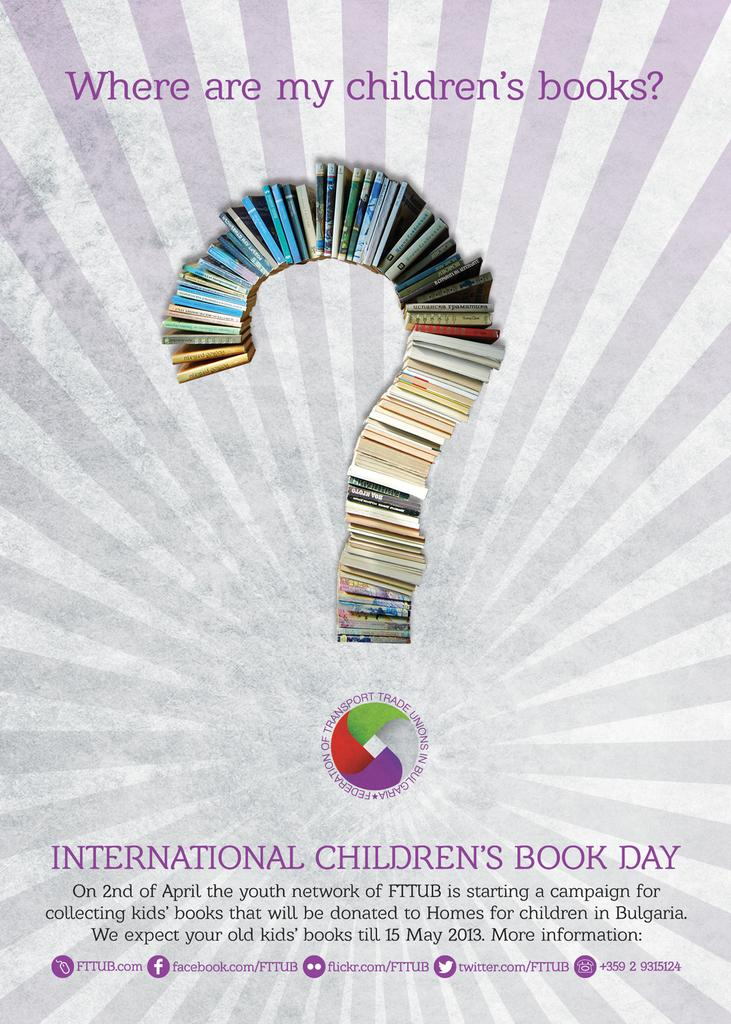<image>
Present a compact description of the photo's key features. a poster for International Children's Book Day with a question mark made of books 